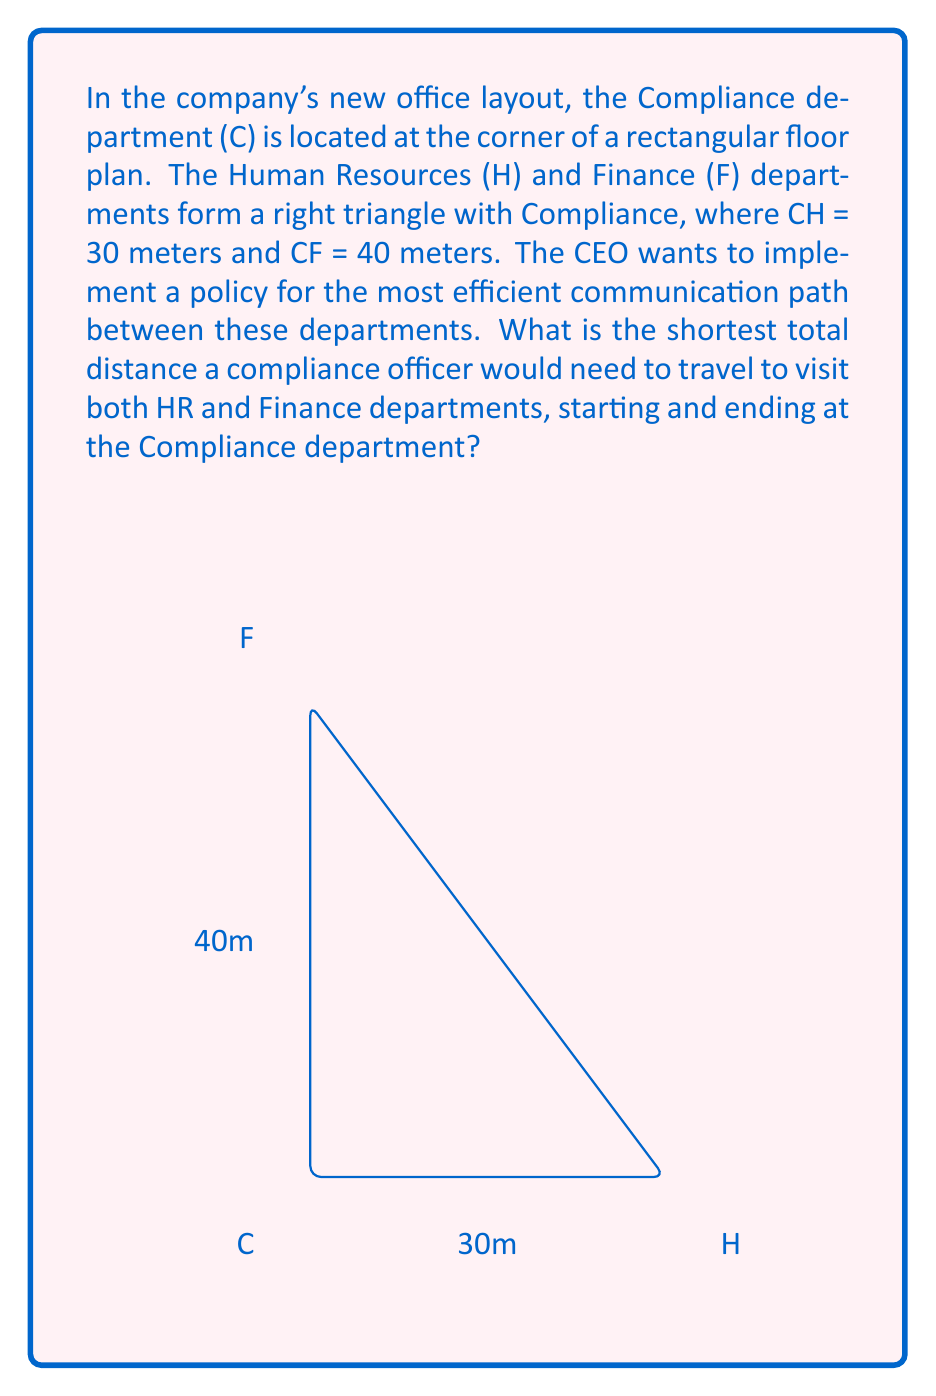Provide a solution to this math problem. Let's approach this step-by-step:

1) First, we need to recognize that this is a right triangle problem, where the Compliance department (C) is at the right angle.

2) We're given two sides of the right triangle:
   CH = 30 meters
   CF = 40 meters

3) To find the shortest total path, we need to consider two options:
   a) C → H → F → C
   b) C → F → H → C

4) The key is to realize that the shortest path will include the hypotenuse HF, as it's always shorter than going around the right angle.

5) To find HF, we can use the Pythagorean theorem:

   $$HF^2 = CH^2 + CF^2$$
   $$HF^2 = 30^2 + 40^2 = 900 + 1600 = 2500$$
   $$HF = \sqrt{2500} = 50\text{ meters}$$

6) Now, the total distance for both paths is the same:
   C → H → F → C = CH + HF + FC = 30 + 50 + 40 = 120 meters

7) Therefore, the shortest total distance to visit both departments and return to Compliance is 120 meters.
Answer: 120 meters 